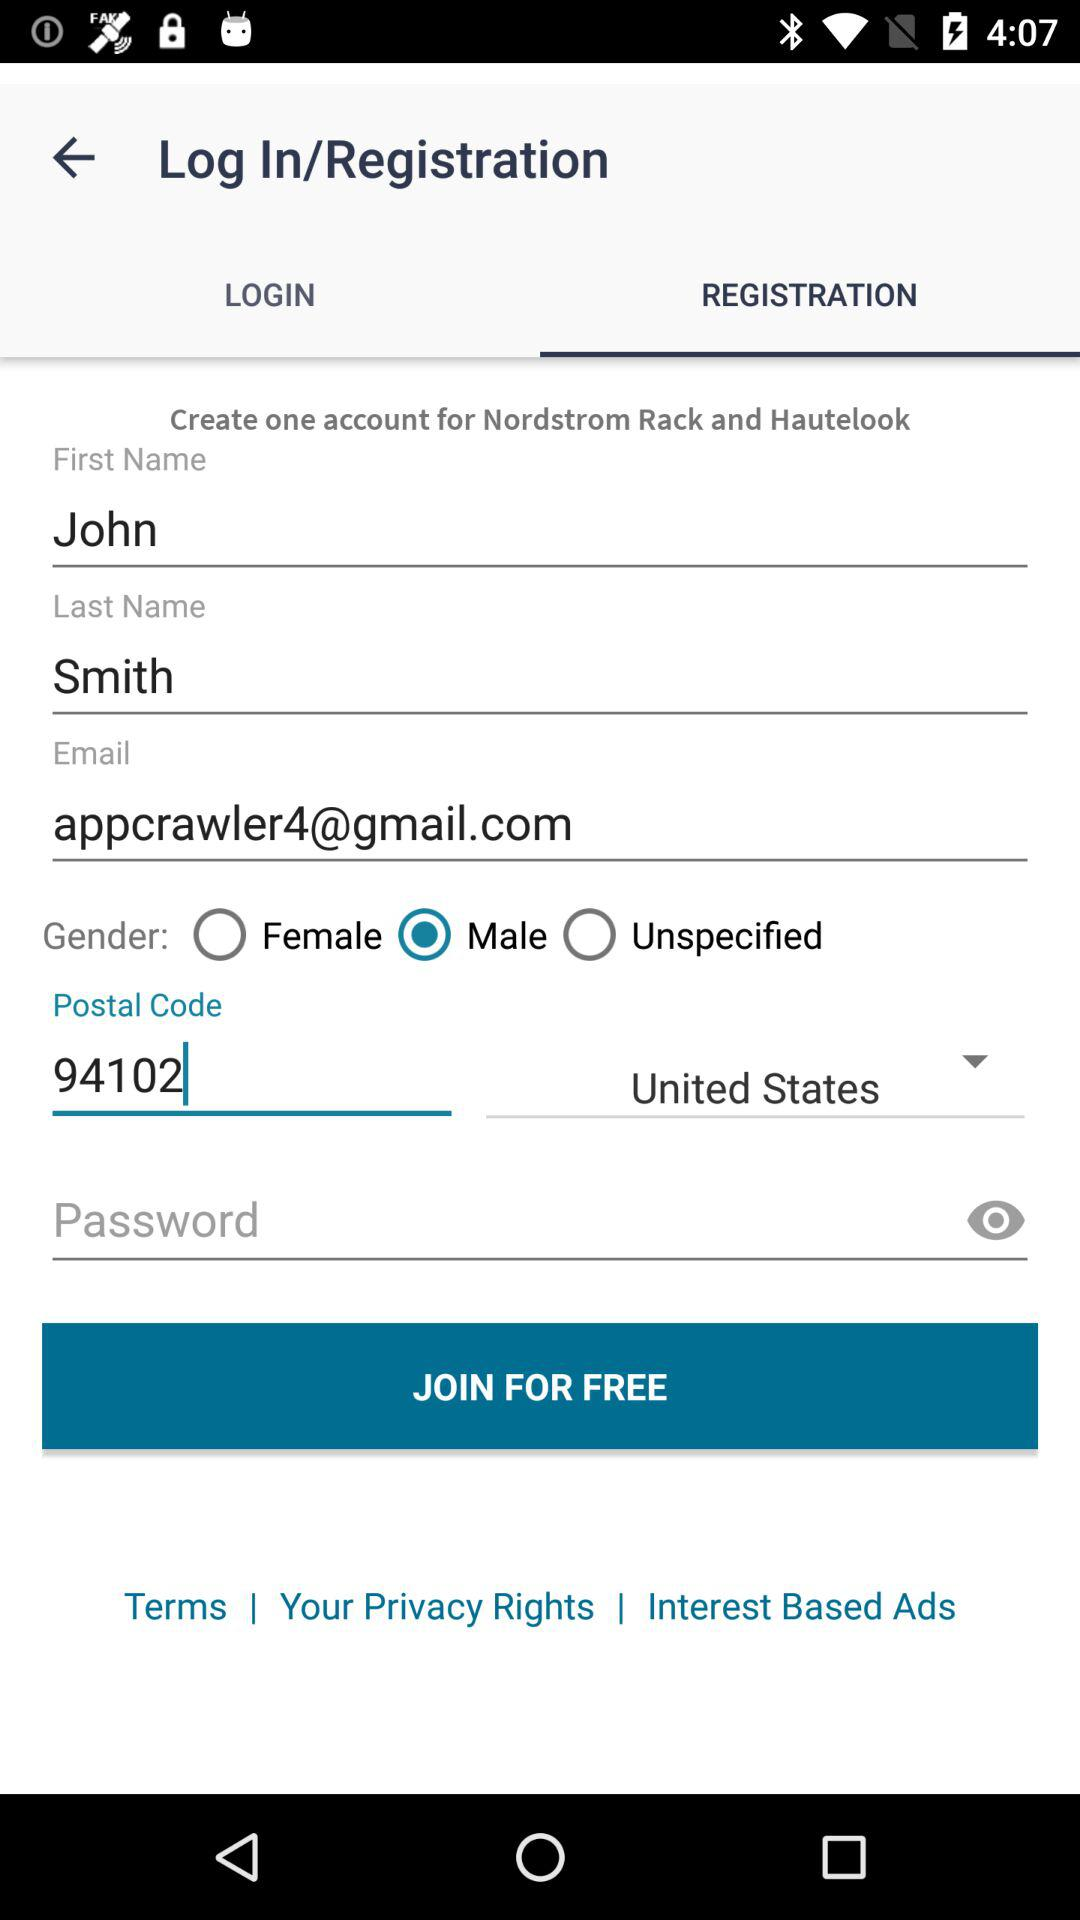What is the last name of the user? The last name of the user is Smith. 